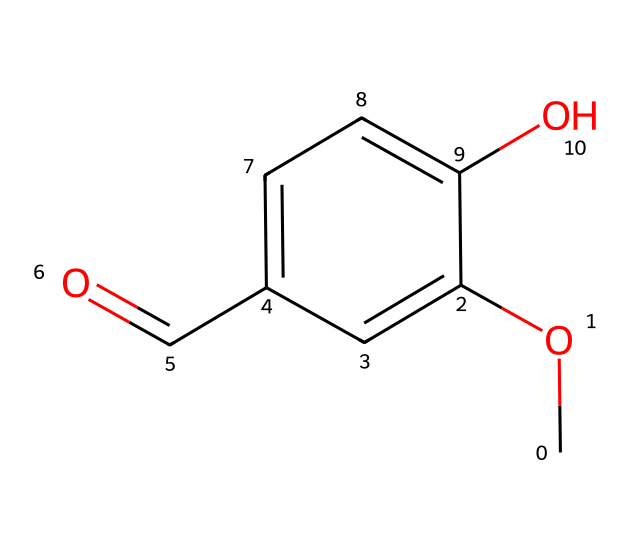What is the molecular formula of vanillin? The SMILES representation indicates the presence of different atoms in the compound. Counting the atoms in the representation, there are 8 carbons (C), 8 hydrogens (H), and 3 oxygens (O). Therefore, the molecular formula is C8H8O3.
Answer: C8H8O3 How many rings are present in this chemical structure? Looking at the SMILES, it indicates that there is one aromatic ring structure, which is denoted by 'c'. There are no other rings present in the chemical structure.
Answer: 1 What type of functional group is present in vanillin? The chemical structure shows a carbonyl group (C=O) and a hydroxyl group (-OH). The presence of these groups indicates that vanillin is an aldehyde (due to the carbonyl at the end of the molecule) and contains a phenolic component (due to the hydroxyl).
Answer: aldehyde What is the primary aromatic functionality in this chemical? The SMILES specifies the presence of 'c' characters, indicating aromatic carbon atoms. The hydroxyl group and the carbonyl group are attached to this aromatic structure, which confirms that this is a phenolic compound.
Answer: phenol What impact does the methoxy group (–OCH3) have on the flavor profile of vanillin? The methoxy group increases the sweetness and overall flavor profile of vanillin, enhancing its pleasant aroma due to its electron-donating characteristics, making it more appealing in food products.
Answer: enhances sweetness How does the hydrogen bond in the hydroxyl group affect vanillin's solubility? The hydroxyl group (-OH) can form hydrogen bonds with water molecules, thus increasing the solubility of vanillin in water. This is critical for its application in foods and beverages, where it must dissolve to impart flavor.
Answer: increases solubility What makes vanillin a common flavoring agent in desserts? Vanillin has a sweet, vanilla-like aroma that is culturally appreciated and widely recognized. This delightful profile, coupled with its functional characteristics, makes it a staple flavoring agent in various dessert recipes.
Answer: sweet aroma 